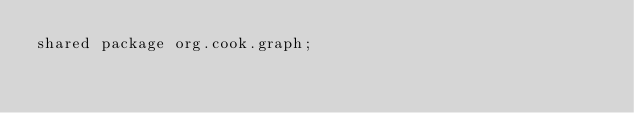<code> <loc_0><loc_0><loc_500><loc_500><_Ceylon_>shared package org.cook.graph;
</code> 